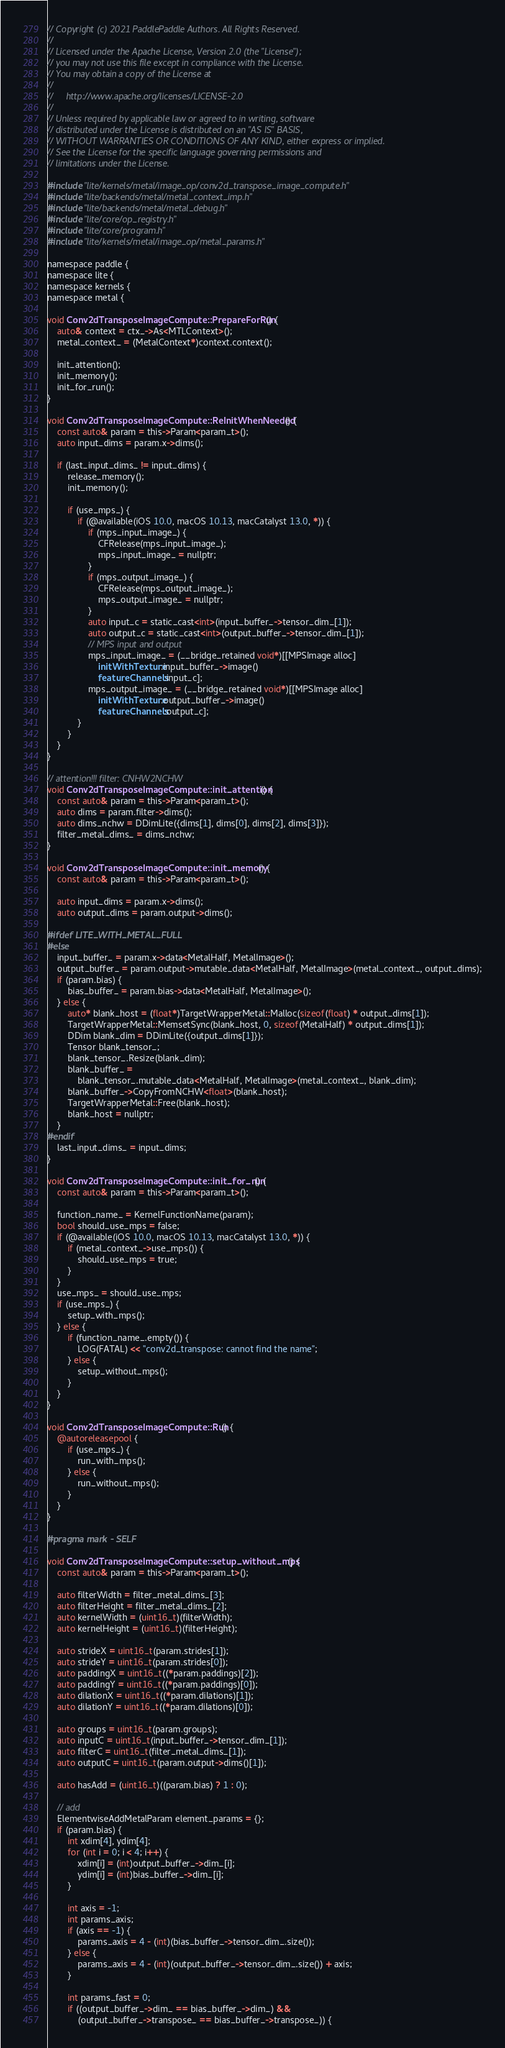<code> <loc_0><loc_0><loc_500><loc_500><_ObjectiveC_>// Copyright (c) 2021 PaddlePaddle Authors. All Rights Reserved.
//
// Licensed under the Apache License, Version 2.0 (the "License");
// you may not use this file except in compliance with the License.
// You may obtain a copy of the License at
//
//     http://www.apache.org/licenses/LICENSE-2.0
//
// Unless required by applicable law or agreed to in writing, software
// distributed under the License is distributed on an "AS IS" BASIS,
// WITHOUT WARRANTIES OR CONDITIONS OF ANY KIND, either express or implied.
// See the License for the specific language governing permissions and
// limitations under the License.

#include "lite/kernels/metal/image_op/conv2d_transpose_image_compute.h"
#include "lite/backends/metal/metal_context_imp.h"
#include "lite/backends/metal/metal_debug.h"
#include "lite/core/op_registry.h"
#include "lite/core/program.h"
#include "lite/kernels/metal/image_op/metal_params.h"

namespace paddle {
namespace lite {
namespace kernels {
namespace metal {

void Conv2dTransposeImageCompute::PrepareForRun() {
    auto& context = ctx_->As<MTLContext>();
    metal_context_ = (MetalContext*)context.context();

    init_attention();
    init_memory();
    init_for_run();
}

void Conv2dTransposeImageCompute::ReInitWhenNeeded() {
    const auto& param = this->Param<param_t>();
    auto input_dims = param.x->dims();

    if (last_input_dims_ != input_dims) {
        release_memory();
        init_memory();

        if (use_mps_) {
            if (@available(iOS 10.0, macOS 10.13, macCatalyst 13.0, *)) {
                if (mps_input_image_) {
                    CFRelease(mps_input_image_);
                    mps_input_image_ = nullptr;
                }
                if (mps_output_image_) {
                    CFRelease(mps_output_image_);
                    mps_output_image_ = nullptr;
                }
                auto input_c = static_cast<int>(input_buffer_->tensor_dim_[1]);
                auto output_c = static_cast<int>(output_buffer_->tensor_dim_[1]);
                // MPS input and output
                mps_input_image_ = (__bridge_retained void*)[[MPSImage alloc]
                    initWithTexture:input_buffer_->image()
                    featureChannels:input_c];
                mps_output_image_ = (__bridge_retained void*)[[MPSImage alloc]
                    initWithTexture:output_buffer_->image()
                    featureChannels:output_c];
            }
        }
    }
}

// attention!!! filter: CNHW2NCHW
void Conv2dTransposeImageCompute::init_attention() {
    const auto& param = this->Param<param_t>();
    auto dims = param.filter->dims();
    auto dims_nchw = DDimLite({dims[1], dims[0], dims[2], dims[3]});
    filter_metal_dims_ = dims_nchw;
}

void Conv2dTransposeImageCompute::init_memory() {
    const auto& param = this->Param<param_t>();

    auto input_dims = param.x->dims();
    auto output_dims = param.output->dims();

#ifdef LITE_WITH_METAL_FULL
#else
    input_buffer_ = param.x->data<MetalHalf, MetalImage>();
    output_buffer_ = param.output->mutable_data<MetalHalf, MetalImage>(metal_context_, output_dims);
    if (param.bias) {
        bias_buffer_ = param.bias->data<MetalHalf, MetalImage>();
    } else {
        auto* blank_host = (float*)TargetWrapperMetal::Malloc(sizeof(float) * output_dims[1]);
        TargetWrapperMetal::MemsetSync(blank_host, 0, sizeof(MetalHalf) * output_dims[1]);
        DDim blank_dim = DDimLite({output_dims[1]});
        Tensor blank_tensor_;
        blank_tensor_.Resize(blank_dim);
        blank_buffer_ =
            blank_tensor_.mutable_data<MetalHalf, MetalImage>(metal_context_, blank_dim);
        blank_buffer_->CopyFromNCHW<float>(blank_host);
        TargetWrapperMetal::Free(blank_host);
        blank_host = nullptr;
    }
#endif
    last_input_dims_ = input_dims;
}

void Conv2dTransposeImageCompute::init_for_run() {
    const auto& param = this->Param<param_t>();

    function_name_ = KernelFunctionName(param);
    bool should_use_mps = false;
    if (@available(iOS 10.0, macOS 10.13, macCatalyst 13.0, *)) {
        if (metal_context_->use_mps()) {
            should_use_mps = true;
        }
    }
    use_mps_ = should_use_mps;
    if (use_mps_) {
        setup_with_mps();
    } else {
        if (function_name_.empty()) {
            LOG(FATAL) << "conv2d_transpose: cannot find the name";
        } else {
            setup_without_mps();
        }
    }
}

void Conv2dTransposeImageCompute::Run() {
    @autoreleasepool {
        if (use_mps_) {
            run_with_mps();
        } else {
            run_without_mps();
        }
    }
}

#pragma mark - SELF

void Conv2dTransposeImageCompute::setup_without_mps() {
    const auto& param = this->Param<param_t>();

    auto filterWidth = filter_metal_dims_[3];
    auto filterHeight = filter_metal_dims_[2];
    auto kernelWidth = (uint16_t)(filterWidth);
    auto kernelHeight = (uint16_t)(filterHeight);

    auto strideX = uint16_t(param.strides[1]);
    auto strideY = uint16_t(param.strides[0]);
    auto paddingX = uint16_t((*param.paddings)[2]);
    auto paddingY = uint16_t((*param.paddings)[0]);
    auto dilationX = uint16_t((*param.dilations)[1]);
    auto dilationY = uint16_t((*param.dilations)[0]);

    auto groups = uint16_t(param.groups);
    auto inputC = uint16_t(input_buffer_->tensor_dim_[1]);
    auto filterC = uint16_t(filter_metal_dims_[1]);
    auto outputC = uint16_t(param.output->dims()[1]);

    auto hasAdd = (uint16_t)((param.bias) ? 1 : 0);

    // add
    ElementwiseAddMetalParam element_params = {};
    if (param.bias) {
        int xdim[4], ydim[4];
        for (int i = 0; i < 4; i++) {
            xdim[i] = (int)output_buffer_->dim_[i];
            ydim[i] = (int)bias_buffer_->dim_[i];
        }

        int axis = -1;
        int params_axis;
        if (axis == -1) {
            params_axis = 4 - (int)(bias_buffer_->tensor_dim_.size());
        } else {
            params_axis = 4 - (int)(output_buffer_->tensor_dim_.size()) + axis;
        }

        int params_fast = 0;
        if ((output_buffer_->dim_ == bias_buffer_->dim_) &&
            (output_buffer_->transpose_ == bias_buffer_->transpose_)) {</code> 